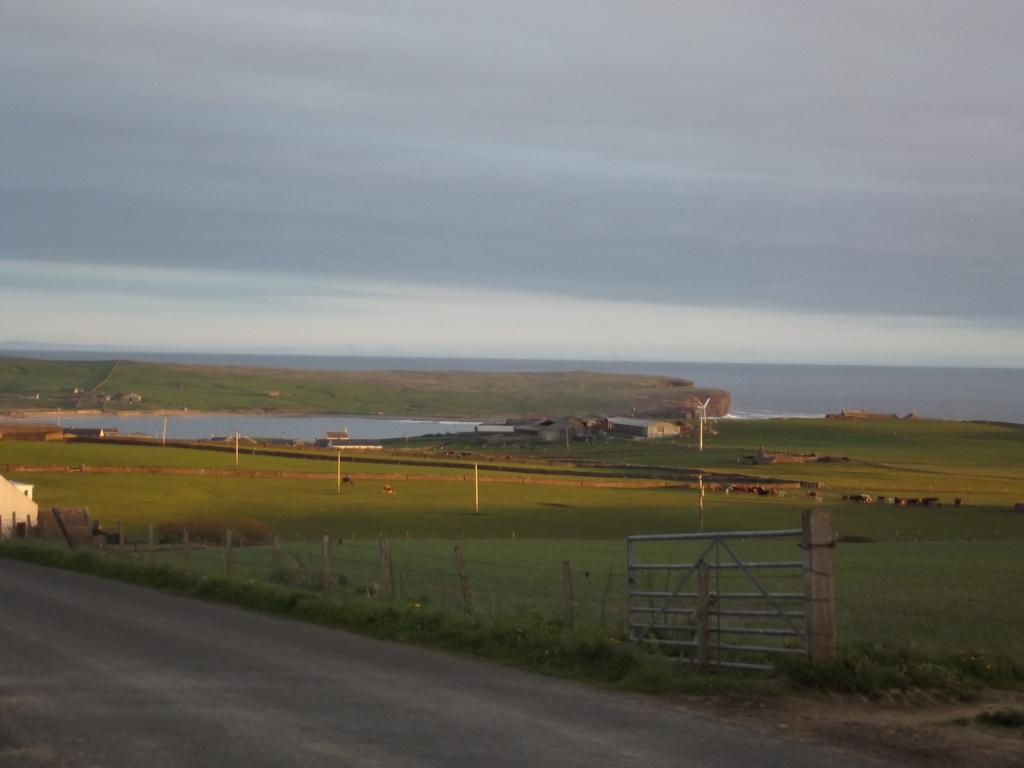What type of surface can be seen in the image? There is a road in the image. What type of vegetation is present in the image? There is grass in the image. What type of barrier is visible in the image? There is fencing in the image. What type of entrance is present in the image? There is a gate in the image. What type of vertical structures can be seen in the image? There are poles in the image. What type of natural feature is visible in the image? There are mountains in the image. What type of ground surface is present in the image? There are stones in the image. What part of the natural environment is visible in the image? The sky is visible in the image. What type of bag is hanging from the mountain in the image? There is no bag present in the image; it features a road, grass, fencing, a gate, poles, water, mountains, stones, and the sky. What month is depicted in the image? The image does not depict a specific month; it is a still image of a landscape. 